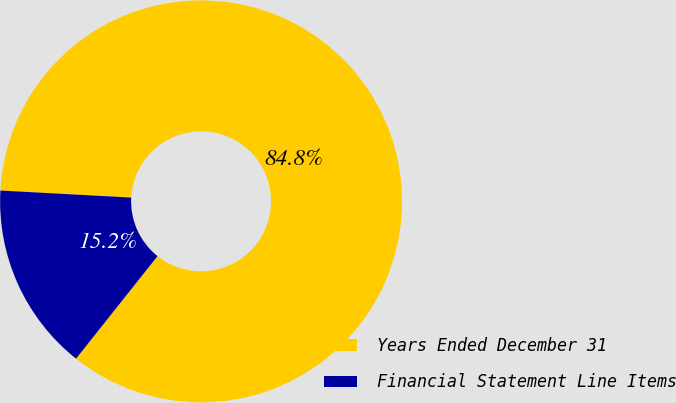<chart> <loc_0><loc_0><loc_500><loc_500><pie_chart><fcel>Years Ended December 31<fcel>Financial Statement Line Items<nl><fcel>84.83%<fcel>15.17%<nl></chart> 